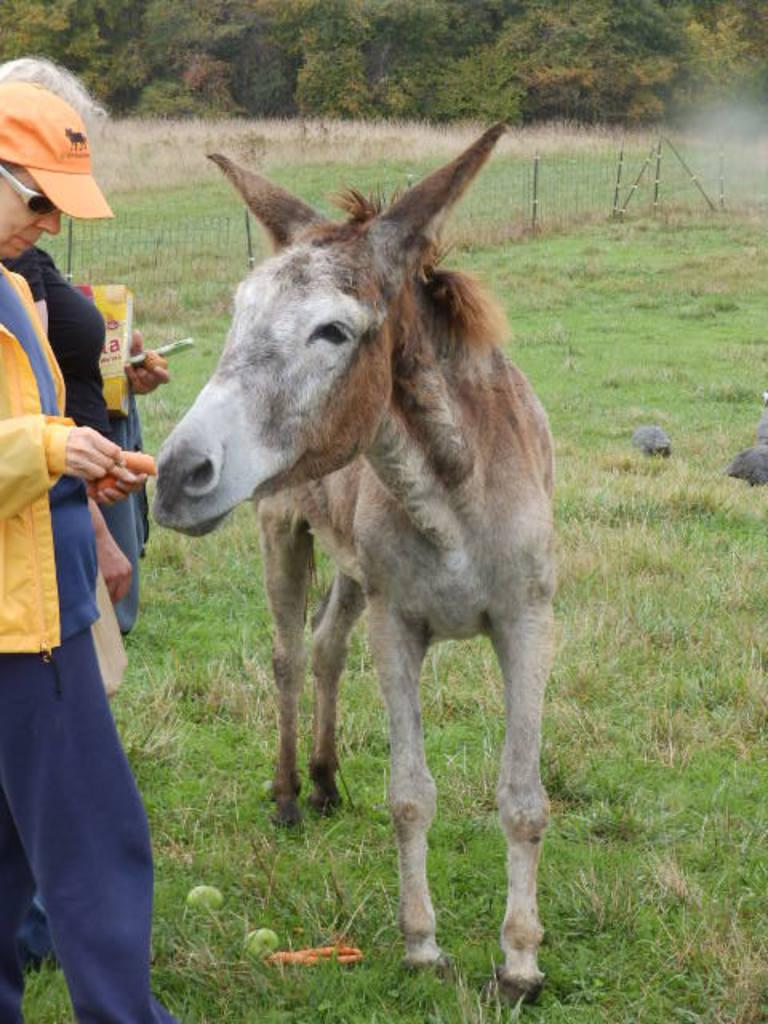What is the main surface visible in the picture? There is a ground in the picture. What animal can be seen on the ground? There is a donkey on the ground. Are there any people present in the image? Yes, there are people standing beside the donkey. What type of barrier is visible in the picture? There is a fence in the picture. What type of vegetation is present on the ground? There is grass on the ground. What other natural elements can be seen in the picture? There are trees in the picture. What type of bead is being distributed by the donkey in the image? There is no bead or distribution activity present in the image. What type of cracker is the donkey eating in the image? There is no cracker present in the image; the donkey is standing on the ground. 